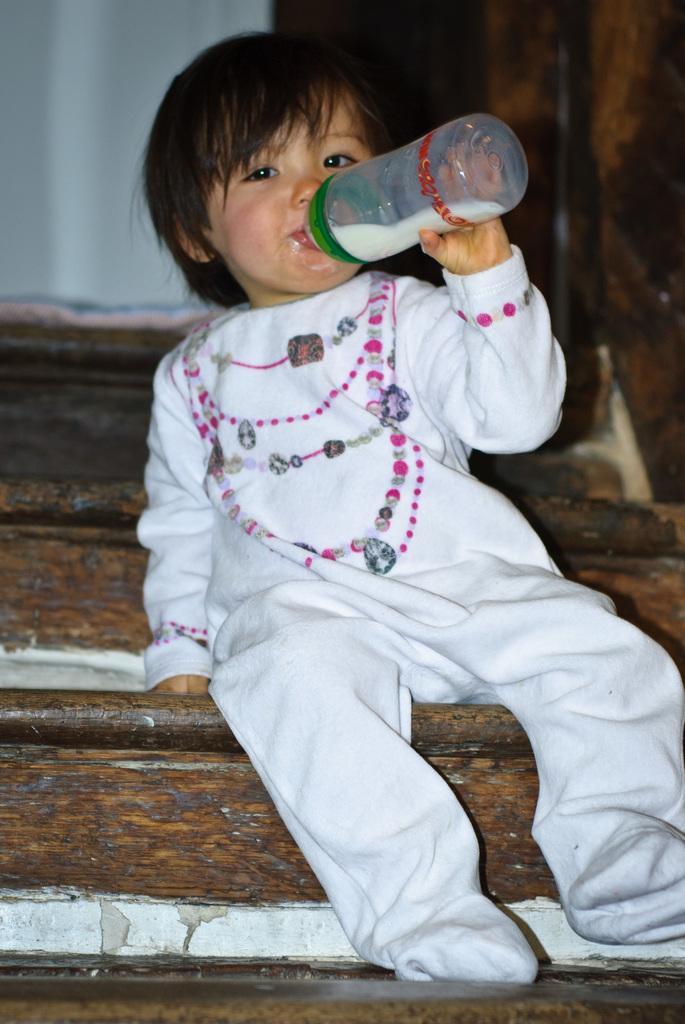Could you give a brief overview of what you see in this image? Bottom right side of the image a kid is sitting on steps and holding a bottle and drinking. 